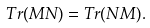<formula> <loc_0><loc_0><loc_500><loc_500>T r ( M N ) = T r ( N M ) .</formula> 